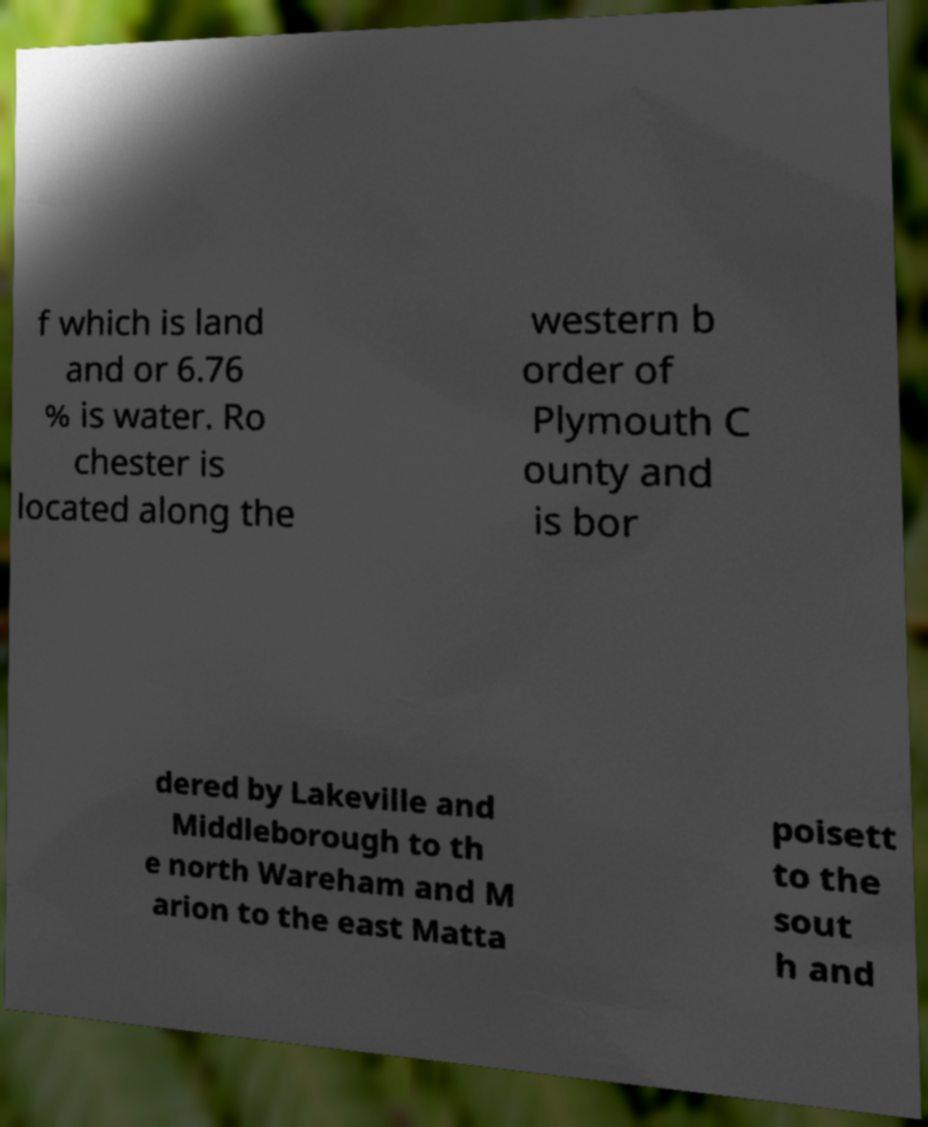Can you read and provide the text displayed in the image?This photo seems to have some interesting text. Can you extract and type it out for me? f which is land and or 6.76 % is water. Ro chester is located along the western b order of Plymouth C ounty and is bor dered by Lakeville and Middleborough to th e north Wareham and M arion to the east Matta poisett to the sout h and 